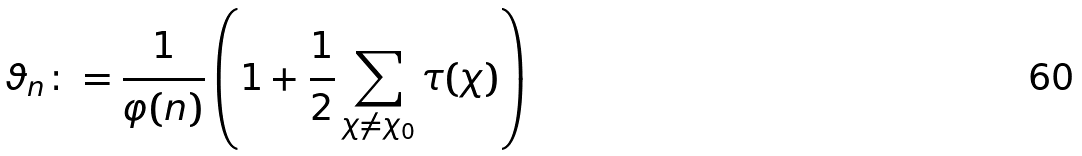<formula> <loc_0><loc_0><loc_500><loc_500>\vartheta _ { n } \colon = \frac { 1 } { \varphi ( n ) } \left ( 1 + \frac { 1 } { 2 } \sum _ { \chi \not = \chi _ { 0 } } \tau ( \chi ) \right )</formula> 